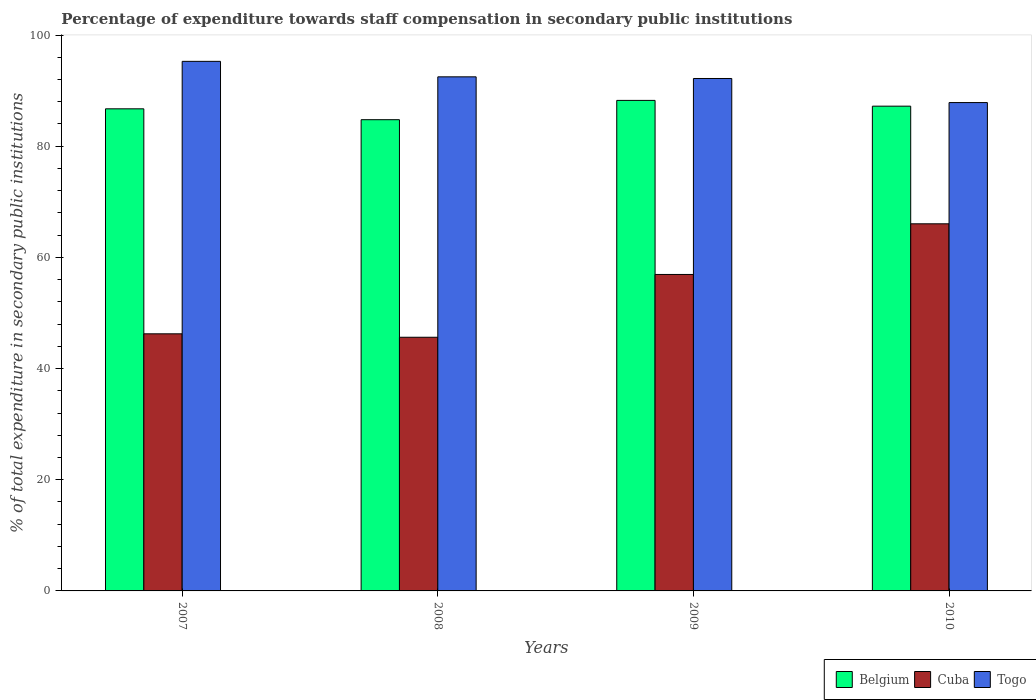How many different coloured bars are there?
Your response must be concise. 3. How many groups of bars are there?
Make the answer very short. 4. How many bars are there on the 3rd tick from the right?
Offer a very short reply. 3. In how many cases, is the number of bars for a given year not equal to the number of legend labels?
Your answer should be very brief. 0. What is the percentage of expenditure towards staff compensation in Togo in 2010?
Offer a very short reply. 87.84. Across all years, what is the maximum percentage of expenditure towards staff compensation in Cuba?
Your answer should be compact. 66.04. Across all years, what is the minimum percentage of expenditure towards staff compensation in Cuba?
Your answer should be very brief. 45.63. In which year was the percentage of expenditure towards staff compensation in Cuba minimum?
Give a very brief answer. 2008. What is the total percentage of expenditure towards staff compensation in Belgium in the graph?
Ensure brevity in your answer.  346.93. What is the difference between the percentage of expenditure towards staff compensation in Belgium in 2007 and that in 2010?
Offer a very short reply. -0.48. What is the difference between the percentage of expenditure towards staff compensation in Togo in 2008 and the percentage of expenditure towards staff compensation in Belgium in 2010?
Provide a short and direct response. 5.28. What is the average percentage of expenditure towards staff compensation in Togo per year?
Offer a terse response. 91.94. In the year 2009, what is the difference between the percentage of expenditure towards staff compensation in Togo and percentage of expenditure towards staff compensation in Belgium?
Your response must be concise. 3.94. What is the ratio of the percentage of expenditure towards staff compensation in Belgium in 2008 to that in 2010?
Offer a terse response. 0.97. What is the difference between the highest and the second highest percentage of expenditure towards staff compensation in Cuba?
Ensure brevity in your answer.  9.11. What is the difference between the highest and the lowest percentage of expenditure towards staff compensation in Cuba?
Your response must be concise. 20.41. Is the sum of the percentage of expenditure towards staff compensation in Belgium in 2007 and 2010 greater than the maximum percentage of expenditure towards staff compensation in Cuba across all years?
Give a very brief answer. Yes. What does the 2nd bar from the left in 2007 represents?
Provide a succinct answer. Cuba. What does the 3rd bar from the right in 2010 represents?
Your answer should be compact. Belgium. Are all the bars in the graph horizontal?
Ensure brevity in your answer.  No. How many years are there in the graph?
Provide a succinct answer. 4. What is the difference between two consecutive major ticks on the Y-axis?
Your answer should be very brief. 20. Are the values on the major ticks of Y-axis written in scientific E-notation?
Give a very brief answer. No. How many legend labels are there?
Your response must be concise. 3. What is the title of the graph?
Your answer should be compact. Percentage of expenditure towards staff compensation in secondary public institutions. Does "Burkina Faso" appear as one of the legend labels in the graph?
Your answer should be compact. No. What is the label or title of the Y-axis?
Your answer should be very brief. % of total expenditure in secondary public institutions. What is the % of total expenditure in secondary public institutions of Belgium in 2007?
Offer a very short reply. 86.72. What is the % of total expenditure in secondary public institutions of Cuba in 2007?
Keep it short and to the point. 46.25. What is the % of total expenditure in secondary public institutions in Togo in 2007?
Keep it short and to the point. 95.26. What is the % of total expenditure in secondary public institutions in Belgium in 2008?
Offer a terse response. 84.77. What is the % of total expenditure in secondary public institutions of Cuba in 2008?
Keep it short and to the point. 45.63. What is the % of total expenditure in secondary public institutions in Togo in 2008?
Ensure brevity in your answer.  92.48. What is the % of total expenditure in secondary public institutions of Belgium in 2009?
Offer a very short reply. 88.24. What is the % of total expenditure in secondary public institutions of Cuba in 2009?
Keep it short and to the point. 56.92. What is the % of total expenditure in secondary public institutions in Togo in 2009?
Provide a succinct answer. 92.18. What is the % of total expenditure in secondary public institutions in Belgium in 2010?
Your answer should be compact. 87.2. What is the % of total expenditure in secondary public institutions of Cuba in 2010?
Provide a succinct answer. 66.04. What is the % of total expenditure in secondary public institutions in Togo in 2010?
Give a very brief answer. 87.84. Across all years, what is the maximum % of total expenditure in secondary public institutions of Belgium?
Your response must be concise. 88.24. Across all years, what is the maximum % of total expenditure in secondary public institutions in Cuba?
Ensure brevity in your answer.  66.04. Across all years, what is the maximum % of total expenditure in secondary public institutions in Togo?
Your answer should be compact. 95.26. Across all years, what is the minimum % of total expenditure in secondary public institutions in Belgium?
Make the answer very short. 84.77. Across all years, what is the minimum % of total expenditure in secondary public institutions in Cuba?
Your answer should be compact. 45.63. Across all years, what is the minimum % of total expenditure in secondary public institutions in Togo?
Your answer should be very brief. 87.84. What is the total % of total expenditure in secondary public institutions in Belgium in the graph?
Keep it short and to the point. 346.93. What is the total % of total expenditure in secondary public institutions of Cuba in the graph?
Your answer should be compact. 214.84. What is the total % of total expenditure in secondary public institutions of Togo in the graph?
Your answer should be very brief. 367.76. What is the difference between the % of total expenditure in secondary public institutions of Belgium in 2007 and that in 2008?
Ensure brevity in your answer.  1.96. What is the difference between the % of total expenditure in secondary public institutions of Cuba in 2007 and that in 2008?
Offer a terse response. 0.62. What is the difference between the % of total expenditure in secondary public institutions in Togo in 2007 and that in 2008?
Your answer should be very brief. 2.78. What is the difference between the % of total expenditure in secondary public institutions of Belgium in 2007 and that in 2009?
Provide a short and direct response. -1.52. What is the difference between the % of total expenditure in secondary public institutions in Cuba in 2007 and that in 2009?
Keep it short and to the point. -10.68. What is the difference between the % of total expenditure in secondary public institutions of Togo in 2007 and that in 2009?
Make the answer very short. 3.08. What is the difference between the % of total expenditure in secondary public institutions of Belgium in 2007 and that in 2010?
Offer a very short reply. -0.48. What is the difference between the % of total expenditure in secondary public institutions in Cuba in 2007 and that in 2010?
Your answer should be very brief. -19.79. What is the difference between the % of total expenditure in secondary public institutions of Togo in 2007 and that in 2010?
Provide a succinct answer. 7.42. What is the difference between the % of total expenditure in secondary public institutions in Belgium in 2008 and that in 2009?
Your answer should be very brief. -3.47. What is the difference between the % of total expenditure in secondary public institutions in Cuba in 2008 and that in 2009?
Offer a terse response. -11.29. What is the difference between the % of total expenditure in secondary public institutions of Togo in 2008 and that in 2009?
Give a very brief answer. 0.3. What is the difference between the % of total expenditure in secondary public institutions in Belgium in 2008 and that in 2010?
Offer a terse response. -2.43. What is the difference between the % of total expenditure in secondary public institutions of Cuba in 2008 and that in 2010?
Offer a terse response. -20.41. What is the difference between the % of total expenditure in secondary public institutions in Togo in 2008 and that in 2010?
Offer a very short reply. 4.63. What is the difference between the % of total expenditure in secondary public institutions in Belgium in 2009 and that in 2010?
Ensure brevity in your answer.  1.04. What is the difference between the % of total expenditure in secondary public institutions in Cuba in 2009 and that in 2010?
Make the answer very short. -9.11. What is the difference between the % of total expenditure in secondary public institutions of Togo in 2009 and that in 2010?
Make the answer very short. 4.33. What is the difference between the % of total expenditure in secondary public institutions of Belgium in 2007 and the % of total expenditure in secondary public institutions of Cuba in 2008?
Ensure brevity in your answer.  41.09. What is the difference between the % of total expenditure in secondary public institutions in Belgium in 2007 and the % of total expenditure in secondary public institutions in Togo in 2008?
Make the answer very short. -5.75. What is the difference between the % of total expenditure in secondary public institutions of Cuba in 2007 and the % of total expenditure in secondary public institutions of Togo in 2008?
Offer a terse response. -46.23. What is the difference between the % of total expenditure in secondary public institutions in Belgium in 2007 and the % of total expenditure in secondary public institutions in Cuba in 2009?
Provide a short and direct response. 29.8. What is the difference between the % of total expenditure in secondary public institutions in Belgium in 2007 and the % of total expenditure in secondary public institutions in Togo in 2009?
Make the answer very short. -5.46. What is the difference between the % of total expenditure in secondary public institutions in Cuba in 2007 and the % of total expenditure in secondary public institutions in Togo in 2009?
Give a very brief answer. -45.93. What is the difference between the % of total expenditure in secondary public institutions in Belgium in 2007 and the % of total expenditure in secondary public institutions in Cuba in 2010?
Your response must be concise. 20.68. What is the difference between the % of total expenditure in secondary public institutions in Belgium in 2007 and the % of total expenditure in secondary public institutions in Togo in 2010?
Your answer should be very brief. -1.12. What is the difference between the % of total expenditure in secondary public institutions of Cuba in 2007 and the % of total expenditure in secondary public institutions of Togo in 2010?
Provide a succinct answer. -41.6. What is the difference between the % of total expenditure in secondary public institutions in Belgium in 2008 and the % of total expenditure in secondary public institutions in Cuba in 2009?
Provide a short and direct response. 27.84. What is the difference between the % of total expenditure in secondary public institutions in Belgium in 2008 and the % of total expenditure in secondary public institutions in Togo in 2009?
Provide a succinct answer. -7.41. What is the difference between the % of total expenditure in secondary public institutions in Cuba in 2008 and the % of total expenditure in secondary public institutions in Togo in 2009?
Provide a short and direct response. -46.55. What is the difference between the % of total expenditure in secondary public institutions of Belgium in 2008 and the % of total expenditure in secondary public institutions of Cuba in 2010?
Make the answer very short. 18.73. What is the difference between the % of total expenditure in secondary public institutions in Belgium in 2008 and the % of total expenditure in secondary public institutions in Togo in 2010?
Ensure brevity in your answer.  -3.08. What is the difference between the % of total expenditure in secondary public institutions in Cuba in 2008 and the % of total expenditure in secondary public institutions in Togo in 2010?
Provide a succinct answer. -42.21. What is the difference between the % of total expenditure in secondary public institutions in Belgium in 2009 and the % of total expenditure in secondary public institutions in Cuba in 2010?
Your response must be concise. 22.2. What is the difference between the % of total expenditure in secondary public institutions of Belgium in 2009 and the % of total expenditure in secondary public institutions of Togo in 2010?
Ensure brevity in your answer.  0.39. What is the difference between the % of total expenditure in secondary public institutions of Cuba in 2009 and the % of total expenditure in secondary public institutions of Togo in 2010?
Your response must be concise. -30.92. What is the average % of total expenditure in secondary public institutions in Belgium per year?
Ensure brevity in your answer.  86.73. What is the average % of total expenditure in secondary public institutions in Cuba per year?
Offer a very short reply. 53.71. What is the average % of total expenditure in secondary public institutions in Togo per year?
Your answer should be very brief. 91.94. In the year 2007, what is the difference between the % of total expenditure in secondary public institutions in Belgium and % of total expenditure in secondary public institutions in Cuba?
Offer a very short reply. 40.47. In the year 2007, what is the difference between the % of total expenditure in secondary public institutions of Belgium and % of total expenditure in secondary public institutions of Togo?
Offer a very short reply. -8.54. In the year 2007, what is the difference between the % of total expenditure in secondary public institutions of Cuba and % of total expenditure in secondary public institutions of Togo?
Provide a succinct answer. -49.01. In the year 2008, what is the difference between the % of total expenditure in secondary public institutions in Belgium and % of total expenditure in secondary public institutions in Cuba?
Offer a very short reply. 39.13. In the year 2008, what is the difference between the % of total expenditure in secondary public institutions in Belgium and % of total expenditure in secondary public institutions in Togo?
Offer a very short reply. -7.71. In the year 2008, what is the difference between the % of total expenditure in secondary public institutions in Cuba and % of total expenditure in secondary public institutions in Togo?
Make the answer very short. -46.85. In the year 2009, what is the difference between the % of total expenditure in secondary public institutions of Belgium and % of total expenditure in secondary public institutions of Cuba?
Give a very brief answer. 31.31. In the year 2009, what is the difference between the % of total expenditure in secondary public institutions of Belgium and % of total expenditure in secondary public institutions of Togo?
Ensure brevity in your answer.  -3.94. In the year 2009, what is the difference between the % of total expenditure in secondary public institutions of Cuba and % of total expenditure in secondary public institutions of Togo?
Your answer should be compact. -35.25. In the year 2010, what is the difference between the % of total expenditure in secondary public institutions in Belgium and % of total expenditure in secondary public institutions in Cuba?
Ensure brevity in your answer.  21.16. In the year 2010, what is the difference between the % of total expenditure in secondary public institutions of Belgium and % of total expenditure in secondary public institutions of Togo?
Give a very brief answer. -0.64. In the year 2010, what is the difference between the % of total expenditure in secondary public institutions of Cuba and % of total expenditure in secondary public institutions of Togo?
Offer a very short reply. -21.81. What is the ratio of the % of total expenditure in secondary public institutions in Belgium in 2007 to that in 2008?
Offer a very short reply. 1.02. What is the ratio of the % of total expenditure in secondary public institutions in Cuba in 2007 to that in 2008?
Offer a terse response. 1.01. What is the ratio of the % of total expenditure in secondary public institutions of Togo in 2007 to that in 2008?
Offer a very short reply. 1.03. What is the ratio of the % of total expenditure in secondary public institutions in Belgium in 2007 to that in 2009?
Offer a terse response. 0.98. What is the ratio of the % of total expenditure in secondary public institutions of Cuba in 2007 to that in 2009?
Offer a very short reply. 0.81. What is the ratio of the % of total expenditure in secondary public institutions of Togo in 2007 to that in 2009?
Ensure brevity in your answer.  1.03. What is the ratio of the % of total expenditure in secondary public institutions in Belgium in 2007 to that in 2010?
Make the answer very short. 0.99. What is the ratio of the % of total expenditure in secondary public institutions of Cuba in 2007 to that in 2010?
Offer a terse response. 0.7. What is the ratio of the % of total expenditure in secondary public institutions of Togo in 2007 to that in 2010?
Offer a very short reply. 1.08. What is the ratio of the % of total expenditure in secondary public institutions in Belgium in 2008 to that in 2009?
Provide a succinct answer. 0.96. What is the ratio of the % of total expenditure in secondary public institutions of Cuba in 2008 to that in 2009?
Your response must be concise. 0.8. What is the ratio of the % of total expenditure in secondary public institutions in Togo in 2008 to that in 2009?
Give a very brief answer. 1. What is the ratio of the % of total expenditure in secondary public institutions in Belgium in 2008 to that in 2010?
Provide a short and direct response. 0.97. What is the ratio of the % of total expenditure in secondary public institutions in Cuba in 2008 to that in 2010?
Ensure brevity in your answer.  0.69. What is the ratio of the % of total expenditure in secondary public institutions of Togo in 2008 to that in 2010?
Keep it short and to the point. 1.05. What is the ratio of the % of total expenditure in secondary public institutions in Belgium in 2009 to that in 2010?
Offer a very short reply. 1.01. What is the ratio of the % of total expenditure in secondary public institutions in Cuba in 2009 to that in 2010?
Your answer should be compact. 0.86. What is the ratio of the % of total expenditure in secondary public institutions in Togo in 2009 to that in 2010?
Ensure brevity in your answer.  1.05. What is the difference between the highest and the second highest % of total expenditure in secondary public institutions of Belgium?
Provide a succinct answer. 1.04. What is the difference between the highest and the second highest % of total expenditure in secondary public institutions in Cuba?
Offer a very short reply. 9.11. What is the difference between the highest and the second highest % of total expenditure in secondary public institutions of Togo?
Make the answer very short. 2.78. What is the difference between the highest and the lowest % of total expenditure in secondary public institutions of Belgium?
Keep it short and to the point. 3.47. What is the difference between the highest and the lowest % of total expenditure in secondary public institutions in Cuba?
Your response must be concise. 20.41. What is the difference between the highest and the lowest % of total expenditure in secondary public institutions of Togo?
Your answer should be compact. 7.42. 